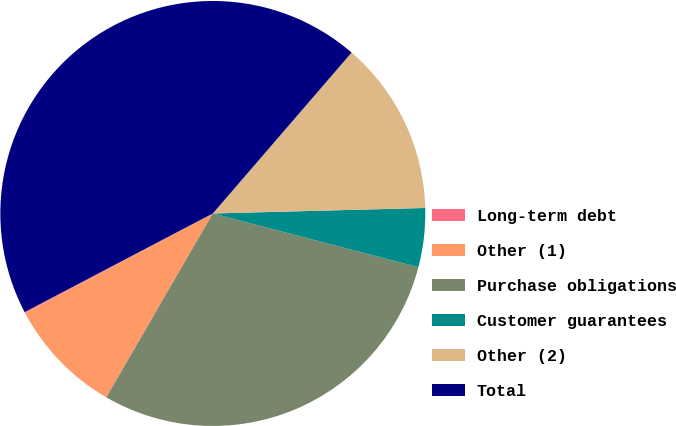Convert chart. <chart><loc_0><loc_0><loc_500><loc_500><pie_chart><fcel>Long-term debt<fcel>Other (1)<fcel>Purchase obligations<fcel>Customer guarantees<fcel>Other (2)<fcel>Total<nl><fcel>0.09%<fcel>8.87%<fcel>29.29%<fcel>4.48%<fcel>13.26%<fcel>44.01%<nl></chart> 